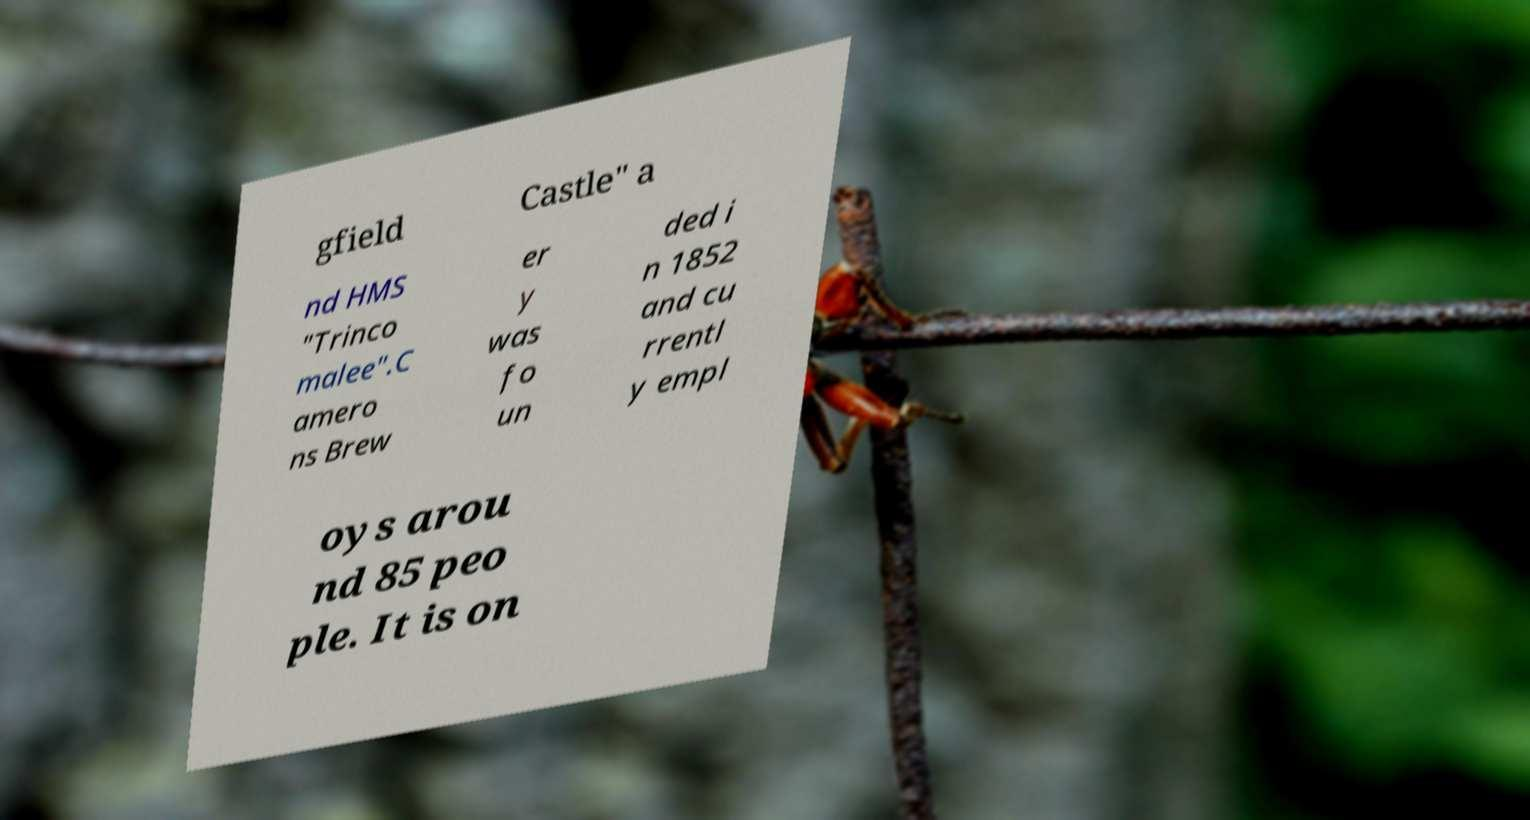There's text embedded in this image that I need extracted. Can you transcribe it verbatim? gfield Castle" a nd HMS "Trinco malee".C amero ns Brew er y was fo un ded i n 1852 and cu rrentl y empl oys arou nd 85 peo ple. It is on 